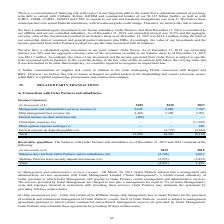According to Golar Lng's financial document, What does Methane Princess lease security deposit movement represent? Based on the financial document, the answer is Net advances from Golar Partners since its IPO, which correspond with the net release of funds from the security deposits held relating to a lease for the Methane Princess. Also, In which years was the receivables (payables) recorded for? The document shows two values: 2019 and 2018. From the document: "(in thousands of $) 2019 2018 2017 Management and administrative services revenue (i) 9,645 9,809 7,762 Ship management fees (in thousands of $) 2019 ..." Also, How often are receivables and payables generally settled? Based on the financial document, the answer is Quarterly in arrears. Additionally, Which year was the balances due (to)/from Golar Partners and its subsidiaries higher? According to the financial document, 2018. The relevant text states: "(in thousands of $) 2019 2018 2017 Management and administrative services revenue (i) 9,645 9,809 7,762 Ship management fees reve..." Also, can you calculate: What was the change in Methane Princess lease security deposit movements between 2018 and 2019? Based on the calculation: (2,253) - (2,835) , the result is 582 (in thousands). This is based on the information: "Princess lease security deposit movements (vii) (2,253) (2,835) Total (4,961) 1,256 s lease security deposit movements (vii) (2,253) (2,835) Total (4,961) 1,256..." The key data points involved are: 2,253, 2,835. Also, can you calculate: What was the percentage change in total between 2018 and 2019? To answer this question, I need to perform calculations using the financial data. The calculation is: ((4,961)- 1,256)/1,256 , which equals -494.98 (percentage). This is based on the information: "ty deposit movements (vii) (2,253) (2,835) Total (4,961) 1,256 sit movements (vii) (2,253) (2,835) Total (4,961) 1,256..." The key data points involved are: 1,256, 4,961. 